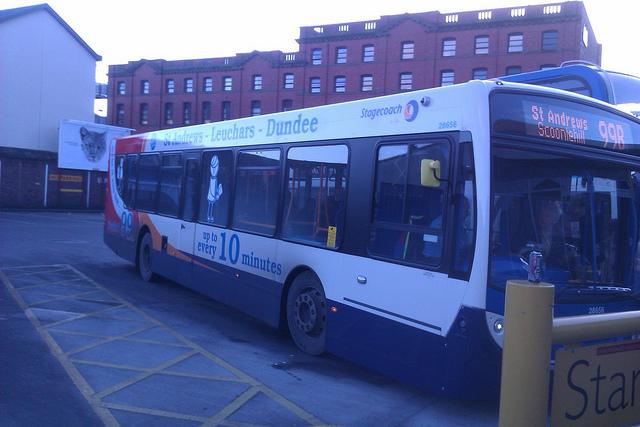What large number is on the bus?
Write a very short answer. 10. Is there a multi-story building in the background?
Concise answer only. Yes. What is the destination on the front of the bus?
Quick response, please. St andrews. 